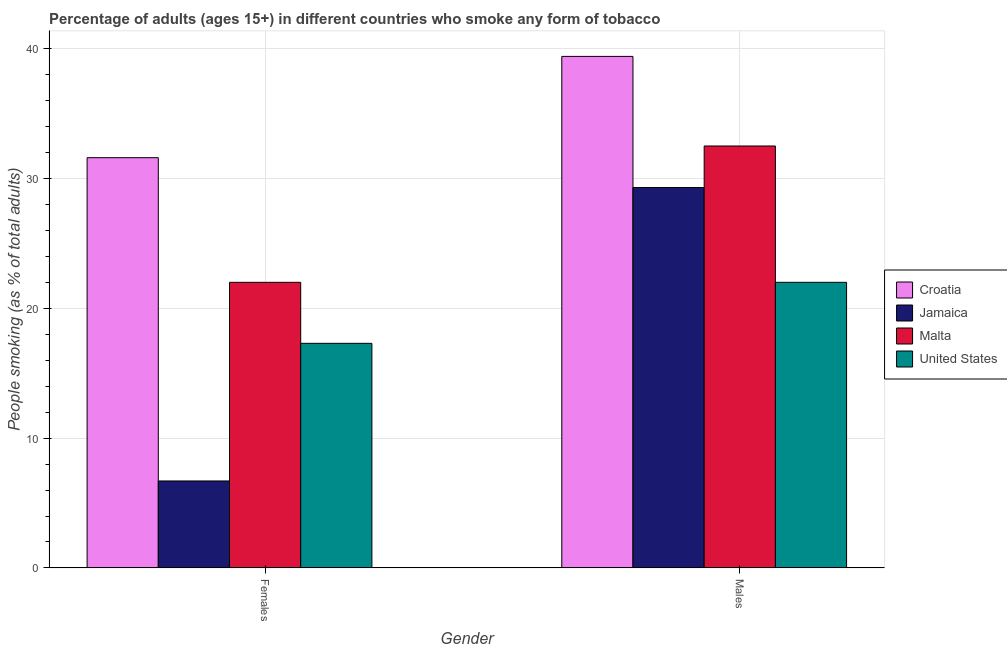How many bars are there on the 2nd tick from the left?
Ensure brevity in your answer.  4. How many bars are there on the 2nd tick from the right?
Provide a succinct answer. 4. What is the label of the 2nd group of bars from the left?
Your response must be concise. Males. Across all countries, what is the maximum percentage of females who smoke?
Provide a short and direct response. 31.6. In which country was the percentage of females who smoke maximum?
Make the answer very short. Croatia. In which country was the percentage of males who smoke minimum?
Keep it short and to the point. United States. What is the total percentage of females who smoke in the graph?
Your answer should be very brief. 77.6. What is the difference between the percentage of males who smoke in United States and that in Croatia?
Your answer should be very brief. -17.4. What is the average percentage of females who smoke per country?
Offer a very short reply. 19.4. What is the difference between the percentage of females who smoke and percentage of males who smoke in United States?
Offer a very short reply. -4.7. What is the ratio of the percentage of females who smoke in Croatia to that in United States?
Your response must be concise. 1.83. What does the 4th bar from the right in Males represents?
Provide a succinct answer. Croatia. How many bars are there?
Keep it short and to the point. 8. How many countries are there in the graph?
Provide a short and direct response. 4. What is the difference between two consecutive major ticks on the Y-axis?
Provide a short and direct response. 10. Are the values on the major ticks of Y-axis written in scientific E-notation?
Offer a very short reply. No. Does the graph contain any zero values?
Provide a short and direct response. No. Does the graph contain grids?
Offer a very short reply. Yes. Where does the legend appear in the graph?
Your answer should be compact. Center right. How are the legend labels stacked?
Offer a terse response. Vertical. What is the title of the graph?
Your answer should be compact. Percentage of adults (ages 15+) in different countries who smoke any form of tobacco. Does "Netherlands" appear as one of the legend labels in the graph?
Your answer should be very brief. No. What is the label or title of the X-axis?
Make the answer very short. Gender. What is the label or title of the Y-axis?
Provide a succinct answer. People smoking (as % of total adults). What is the People smoking (as % of total adults) in Croatia in Females?
Offer a very short reply. 31.6. What is the People smoking (as % of total adults) of Jamaica in Females?
Provide a succinct answer. 6.7. What is the People smoking (as % of total adults) in Malta in Females?
Ensure brevity in your answer.  22. What is the People smoking (as % of total adults) in Croatia in Males?
Ensure brevity in your answer.  39.4. What is the People smoking (as % of total adults) in Jamaica in Males?
Ensure brevity in your answer.  29.3. What is the People smoking (as % of total adults) in Malta in Males?
Your response must be concise. 32.5. What is the People smoking (as % of total adults) in United States in Males?
Provide a short and direct response. 22. Across all Gender, what is the maximum People smoking (as % of total adults) of Croatia?
Your answer should be very brief. 39.4. Across all Gender, what is the maximum People smoking (as % of total adults) in Jamaica?
Make the answer very short. 29.3. Across all Gender, what is the maximum People smoking (as % of total adults) in Malta?
Your response must be concise. 32.5. Across all Gender, what is the maximum People smoking (as % of total adults) in United States?
Offer a terse response. 22. Across all Gender, what is the minimum People smoking (as % of total adults) of Croatia?
Keep it short and to the point. 31.6. What is the total People smoking (as % of total adults) of Croatia in the graph?
Keep it short and to the point. 71. What is the total People smoking (as % of total adults) of Malta in the graph?
Offer a very short reply. 54.5. What is the total People smoking (as % of total adults) in United States in the graph?
Keep it short and to the point. 39.3. What is the difference between the People smoking (as % of total adults) of Croatia in Females and that in Males?
Your answer should be compact. -7.8. What is the difference between the People smoking (as % of total adults) in Jamaica in Females and that in Males?
Give a very brief answer. -22.6. What is the difference between the People smoking (as % of total adults) of Croatia in Females and the People smoking (as % of total adults) of Jamaica in Males?
Provide a short and direct response. 2.3. What is the difference between the People smoking (as % of total adults) of Jamaica in Females and the People smoking (as % of total adults) of Malta in Males?
Your response must be concise. -25.8. What is the difference between the People smoking (as % of total adults) of Jamaica in Females and the People smoking (as % of total adults) of United States in Males?
Your answer should be very brief. -15.3. What is the difference between the People smoking (as % of total adults) of Malta in Females and the People smoking (as % of total adults) of United States in Males?
Ensure brevity in your answer.  0. What is the average People smoking (as % of total adults) of Croatia per Gender?
Provide a short and direct response. 35.5. What is the average People smoking (as % of total adults) in Malta per Gender?
Keep it short and to the point. 27.25. What is the average People smoking (as % of total adults) of United States per Gender?
Make the answer very short. 19.65. What is the difference between the People smoking (as % of total adults) in Croatia and People smoking (as % of total adults) in Jamaica in Females?
Provide a succinct answer. 24.9. What is the difference between the People smoking (as % of total adults) in Croatia and People smoking (as % of total adults) in Malta in Females?
Ensure brevity in your answer.  9.6. What is the difference between the People smoking (as % of total adults) of Croatia and People smoking (as % of total adults) of United States in Females?
Give a very brief answer. 14.3. What is the difference between the People smoking (as % of total adults) of Jamaica and People smoking (as % of total adults) of Malta in Females?
Provide a succinct answer. -15.3. What is the difference between the People smoking (as % of total adults) of Malta and People smoking (as % of total adults) of United States in Females?
Your answer should be compact. 4.7. What is the difference between the People smoking (as % of total adults) of Croatia and People smoking (as % of total adults) of Malta in Males?
Provide a short and direct response. 6.9. What is the difference between the People smoking (as % of total adults) of Jamaica and People smoking (as % of total adults) of Malta in Males?
Keep it short and to the point. -3.2. What is the difference between the People smoking (as % of total adults) of Jamaica and People smoking (as % of total adults) of United States in Males?
Provide a short and direct response. 7.3. What is the ratio of the People smoking (as % of total adults) of Croatia in Females to that in Males?
Your answer should be very brief. 0.8. What is the ratio of the People smoking (as % of total adults) of Jamaica in Females to that in Males?
Offer a very short reply. 0.23. What is the ratio of the People smoking (as % of total adults) in Malta in Females to that in Males?
Make the answer very short. 0.68. What is the ratio of the People smoking (as % of total adults) of United States in Females to that in Males?
Your answer should be compact. 0.79. What is the difference between the highest and the second highest People smoking (as % of total adults) of Croatia?
Offer a very short reply. 7.8. What is the difference between the highest and the second highest People smoking (as % of total adults) in Jamaica?
Ensure brevity in your answer.  22.6. What is the difference between the highest and the second highest People smoking (as % of total adults) of Malta?
Offer a very short reply. 10.5. What is the difference between the highest and the lowest People smoking (as % of total adults) of Jamaica?
Provide a short and direct response. 22.6. What is the difference between the highest and the lowest People smoking (as % of total adults) of United States?
Offer a very short reply. 4.7. 